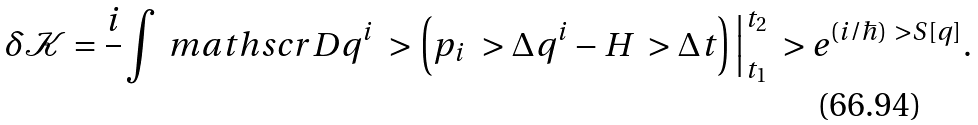<formula> <loc_0><loc_0><loc_500><loc_500>\delta \mathcal { K } & = \frac { i } { } \int \ m a t h s c r { D } q ^ { i } \ > \left ( p _ { i } \ > \Delta q ^ { i } - H \ > \Delta t \right ) \Big | ^ { t _ { 2 } } _ { t _ { 1 } } \ > e ^ { ( i / \hbar { ) } \ > S [ q ] } .</formula> 